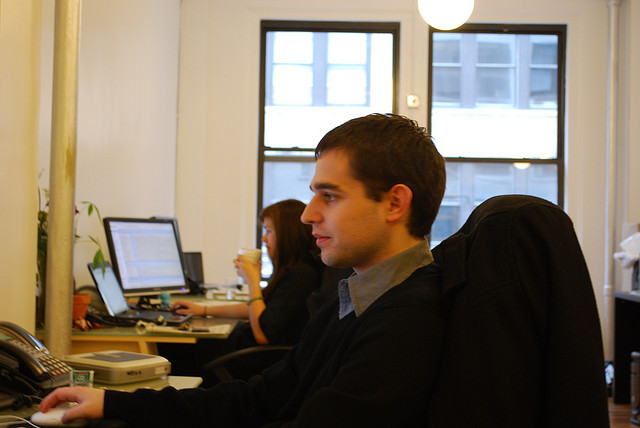<image>What is this kind of work setting? The kind of work setting is not clear. Most of the responses suggest it's an office, but it could also be a casual setting. What is this kind of work setting? I don't know what kind of work setting this is. It can be an office or a casual setting. 